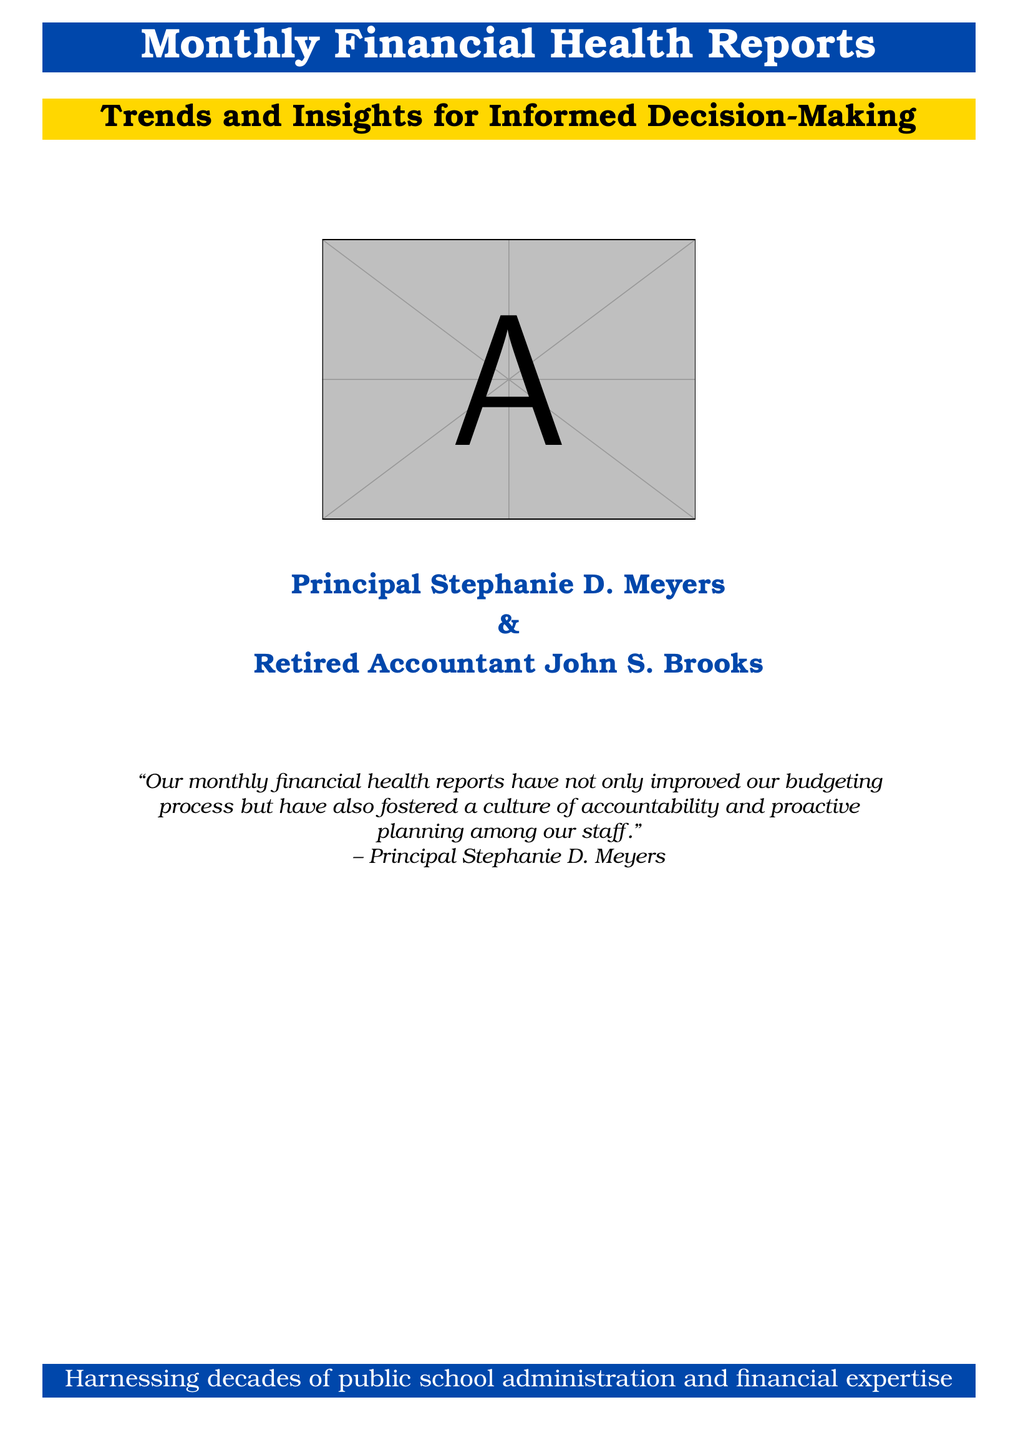What is the title of the document? The title is explicitly stated at the top of the document inside a colorbox.
Answer: Monthly Financial Health Reports Who is the primary author of the document? The name of the primary author is clearly stated below the title.
Answer: Principal Stephanie D. Meyers What color is used for the title background? The background color for the title section is specified in the document setup.
Answer: Main color What is the subtitle of the document? The subtitle is presented immediately following the title and is clearly defined.
Answer: Trends and Insights for Informed Decision-Making Who is the secondary author of the document? The name of the secondary author is mentioned along with the primary author.
Answer: Retired Accountant John S. Brooks What quote is included in the document? The quote attributed to Principal Stephanie D. Meyers summarizes the benefits of the reports.
Answer: "Our monthly financial health reports have not only improved our budgeting process but have also fostered a culture of accountability and proactive planning among our staff." What is the main purpose of the financial health reports according to the quote? The purpose is summarized in the quote regarding the budgeting process and culture.
Answer: Improved budgeting process How does the document describe its expertise? The document concludes with a statement about the background of the authors and their experience.
Answer: Decades of public school administration and financial expertise 